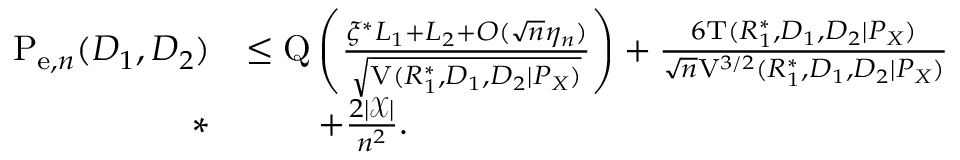<formula> <loc_0><loc_0><loc_500><loc_500>\begin{array} { r l } { P _ { e , n } ( D _ { 1 } , D _ { 2 } ) } & { \leq Q \left ( \frac { \xi ^ { * } L _ { 1 } + L _ { 2 } + O ( \sqrt { n } \eta _ { n } ) } { \sqrt { V ( R _ { 1 } ^ { * } , D _ { 1 } , D _ { 2 } | P _ { X } ) } } \right ) + \frac { 6 T ( R _ { 1 } ^ { * } , D _ { 1 } , D _ { 2 } | P _ { X } ) } { \sqrt { n } V ^ { 3 / 2 } ( R _ { 1 } ^ { * } , D _ { 1 } , D _ { 2 } | P _ { X } ) } } \\ { * } & { \quad + \frac { 2 | \mathcal { X } | } { n ^ { 2 } } . } \end{array}</formula> 